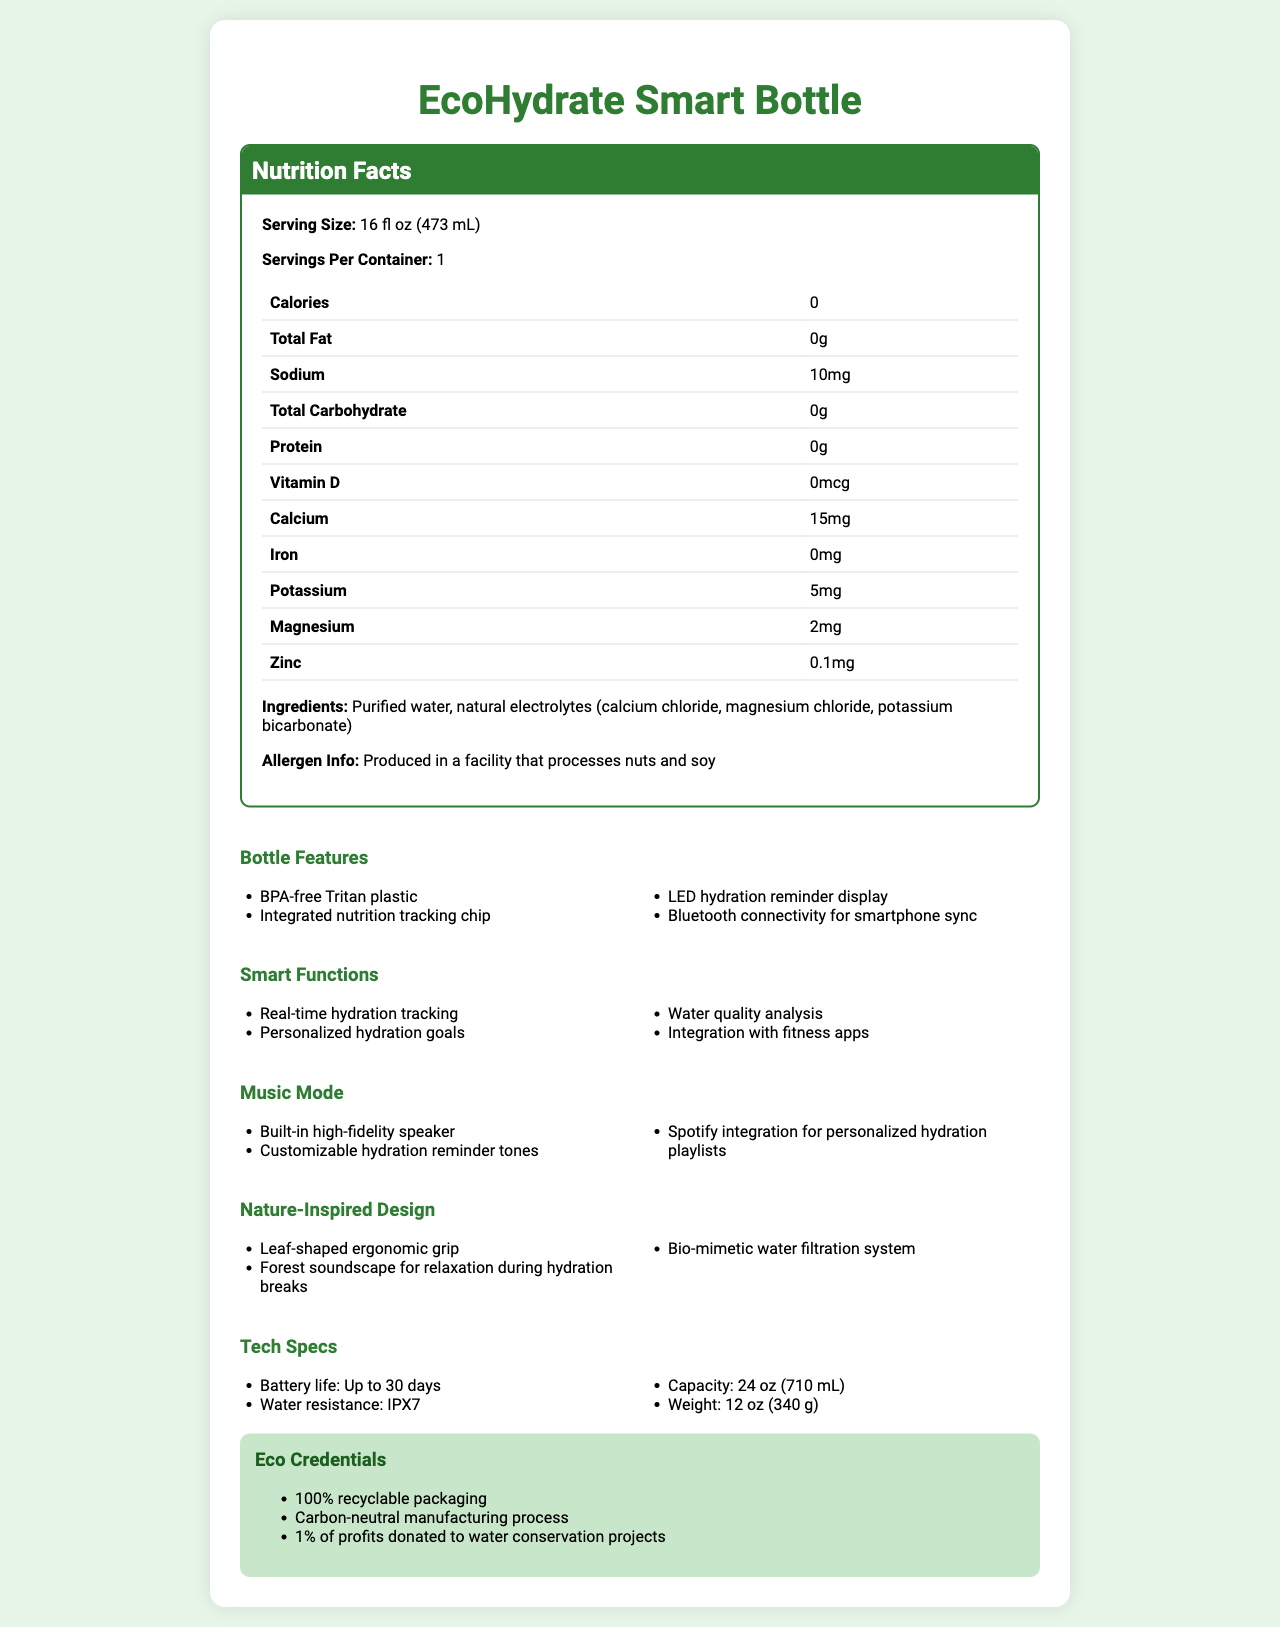what is the serving size for the EcoHydrate Smart Bottle? The serving size is clearly indicated as 16 fl oz (473 mL) within the nutrition label section of the document.
Answer: 16 fl oz (473 mL) how many calories are in one serving of the EcoHydrate Smart Bottle? The nutrition label shows that the product contains 0 calories.
Answer: 0 how much calcium is present in the EcoHydrate Smart Bottle? The amount of calcium is listed in the nutrition facts as 15mg.
Answer: 15mg is the EcoHydrate Smart Bottle produced in a facility that processes nuts and soy? The allergen info states that the product is produced in a facility that processes nuts and soy.
Answer: Yes what are the three main electrolytes in the EcoHydrate Smart Bottle? The ingredients list mentions purified water and natural electrolytes: calcium chloride, magnesium chloride, potassium bicarbonate.
Answer: Calcium chloride, magnesium chloride, potassium bicarbonate what are the smart functions of the EcoHydrate Smart Bottle? The document lists multiple smart functions under a separate heading.
Answer: Real-time hydration tracking, Personalized hydration goals, Water quality analysis, Integration with fitness apps which of the following is NOT a feature of the EcoHydrate Smart Bottle? A. Built-in high-fidelity speaker B. Solar charging capability C. Bluetooth connectivity for smartphone sync The listed features include a high-fidelity speaker and Bluetooth connectivity, but there is no mention of solar charging capability.
Answer: B which certification is held by the EcoHydrate Smart Bottle? A. FDA approved B. Certified Humane C. Fair Trade certified The document mentions that the bottle is FDA approved, but does not mention Certified Humane or Fair Trade certified.
Answer: A does the EcoHydrate Smart Bottle have Spotify integration for personalized hydration playlists? One of the listed features in the music mode section includes Spotify integration for personalized hydration playlists.
Answer: Yes summarize the main features and benefits of the EcoHydrate Smart Bottle. This summary encompasses the different sections of the document, including smart functions, eco credentials, and the nature-inspired design.
Answer: The EcoHydrate Smart Bottle is a technologically advanced hydration solution with features like real-time hydration tracking, Bluetooth connectivity, and personalized hydration goals. It integrates with fitness apps and Spotify, boasts eco-friendly credentials, and offers a nature-inspired design. Additionally, it includes essential electrolytes and minerals and emphasizes sustainability through recyclable packaging and carbon-neutral manufacturing. how many grams of protein are in the EcoHydrate Smart Bottle? The nutrition facts state that the product contains 0 grams of protein.
Answer: 0g how long is the battery life of the EcoHydrate Smart Bottle? The technical specifications mention that the battery life is up to 30 days.
Answer: Up to 30 days what are the eco credentials of the EcoHydrate Smart Bottle? The document lists these eco credentials under a dedicated section.
Answer: 100% recyclable packaging, Carbon-neutral manufacturing process, 1% of profits donated to water conservation projects how many servings are there per container of the EcoHydrate Smart Bottle? The nutrition facts detail that each container holds one serving.
Answer: 1 what is the total carbohydrate content in the EcoHydrate Smart Bottle? The nutrition facts section indicates that the total carbohydrate content is 0 grams.
Answer: 0g what is the recommended daily water intake according to the EcoHydrate Smart Bottle's documentation? The document recommends a daily intake of 8 bottles, amounting to a total of 128 fl oz.
Answer: 8 bottles (128 fl oz) what exact role does the built-in high-fidelity speaker play in hydration tracking? The document does not provide specific details about the speaker's role in hydration tracking. It only mentions the speaker as part of the music mode feature.
Answer: Not enough information 